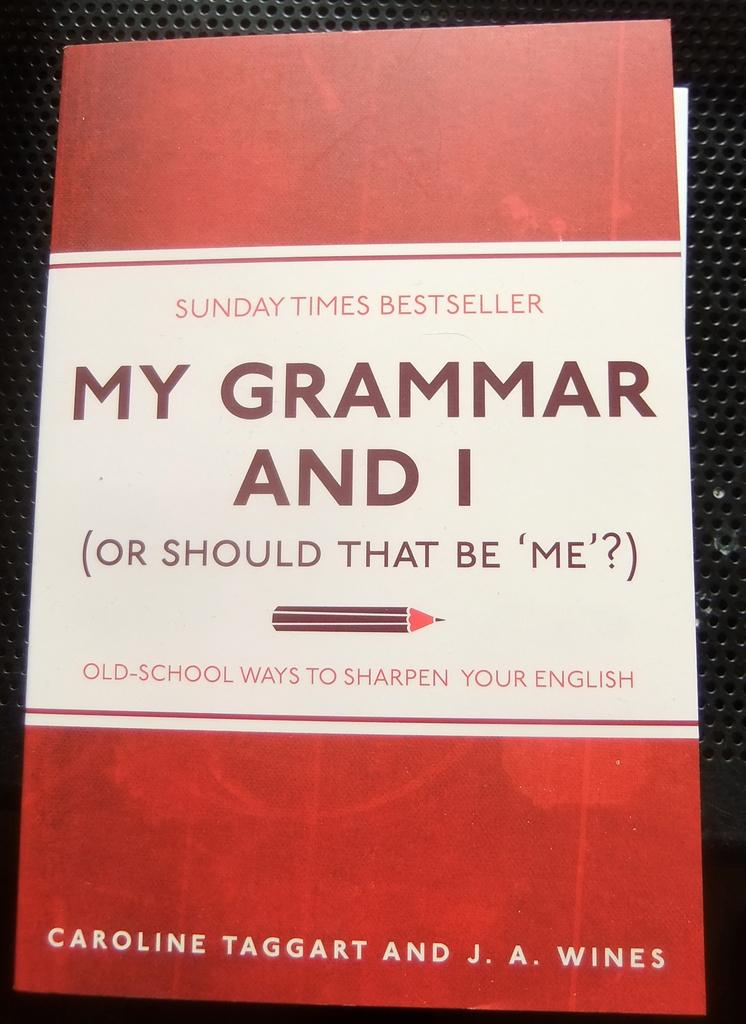<image>
Present a compact description of the photo's key features. An old book entitled: "My Grammar and I" 